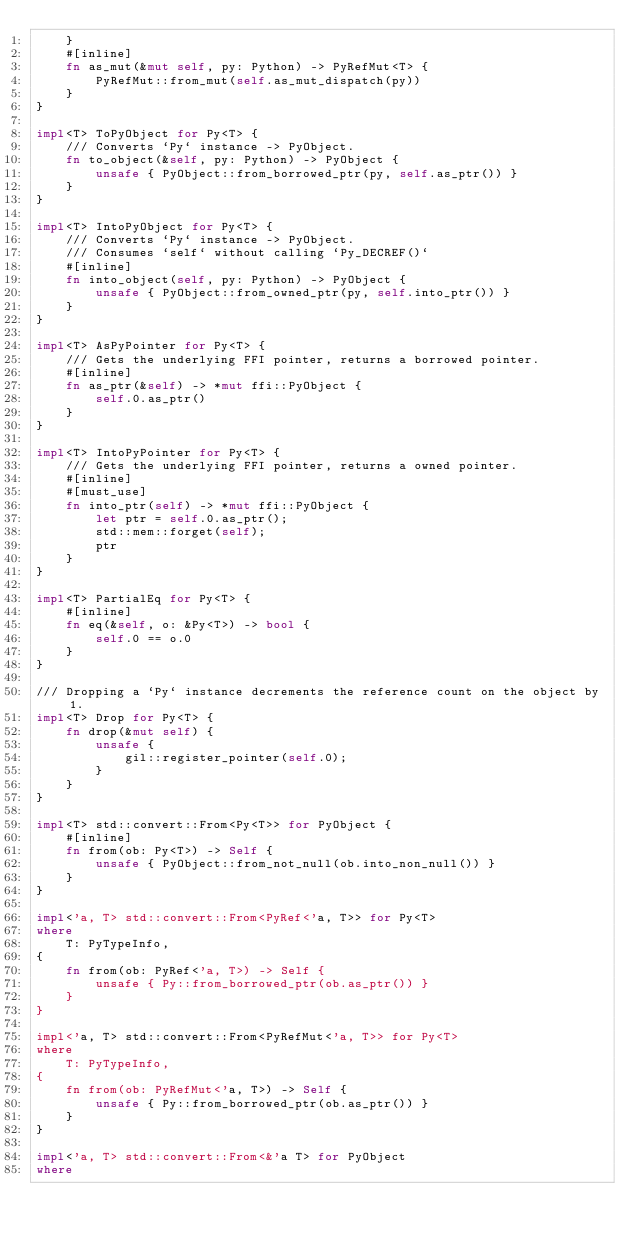<code> <loc_0><loc_0><loc_500><loc_500><_Rust_>    }
    #[inline]
    fn as_mut(&mut self, py: Python) -> PyRefMut<T> {
        PyRefMut::from_mut(self.as_mut_dispatch(py))
    }
}

impl<T> ToPyObject for Py<T> {
    /// Converts `Py` instance -> PyObject.
    fn to_object(&self, py: Python) -> PyObject {
        unsafe { PyObject::from_borrowed_ptr(py, self.as_ptr()) }
    }
}

impl<T> IntoPyObject for Py<T> {
    /// Converts `Py` instance -> PyObject.
    /// Consumes `self` without calling `Py_DECREF()`
    #[inline]
    fn into_object(self, py: Python) -> PyObject {
        unsafe { PyObject::from_owned_ptr(py, self.into_ptr()) }
    }
}

impl<T> AsPyPointer for Py<T> {
    /// Gets the underlying FFI pointer, returns a borrowed pointer.
    #[inline]
    fn as_ptr(&self) -> *mut ffi::PyObject {
        self.0.as_ptr()
    }
}

impl<T> IntoPyPointer for Py<T> {
    /// Gets the underlying FFI pointer, returns a owned pointer.
    #[inline]
    #[must_use]
    fn into_ptr(self) -> *mut ffi::PyObject {
        let ptr = self.0.as_ptr();
        std::mem::forget(self);
        ptr
    }
}

impl<T> PartialEq for Py<T> {
    #[inline]
    fn eq(&self, o: &Py<T>) -> bool {
        self.0 == o.0
    }
}

/// Dropping a `Py` instance decrements the reference count on the object by 1.
impl<T> Drop for Py<T> {
    fn drop(&mut self) {
        unsafe {
            gil::register_pointer(self.0);
        }
    }
}

impl<T> std::convert::From<Py<T>> for PyObject {
    #[inline]
    fn from(ob: Py<T>) -> Self {
        unsafe { PyObject::from_not_null(ob.into_non_null()) }
    }
}

impl<'a, T> std::convert::From<PyRef<'a, T>> for Py<T>
where
    T: PyTypeInfo,
{
    fn from(ob: PyRef<'a, T>) -> Self {
        unsafe { Py::from_borrowed_ptr(ob.as_ptr()) }
    }
}

impl<'a, T> std::convert::From<PyRefMut<'a, T>> for Py<T>
where
    T: PyTypeInfo,
{
    fn from(ob: PyRefMut<'a, T>) -> Self {
        unsafe { Py::from_borrowed_ptr(ob.as_ptr()) }
    }
}

impl<'a, T> std::convert::From<&'a T> for PyObject
where</code> 